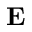<formula> <loc_0><loc_0><loc_500><loc_500>E</formula> 